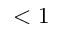<formula> <loc_0><loc_0><loc_500><loc_500>< 1</formula> 